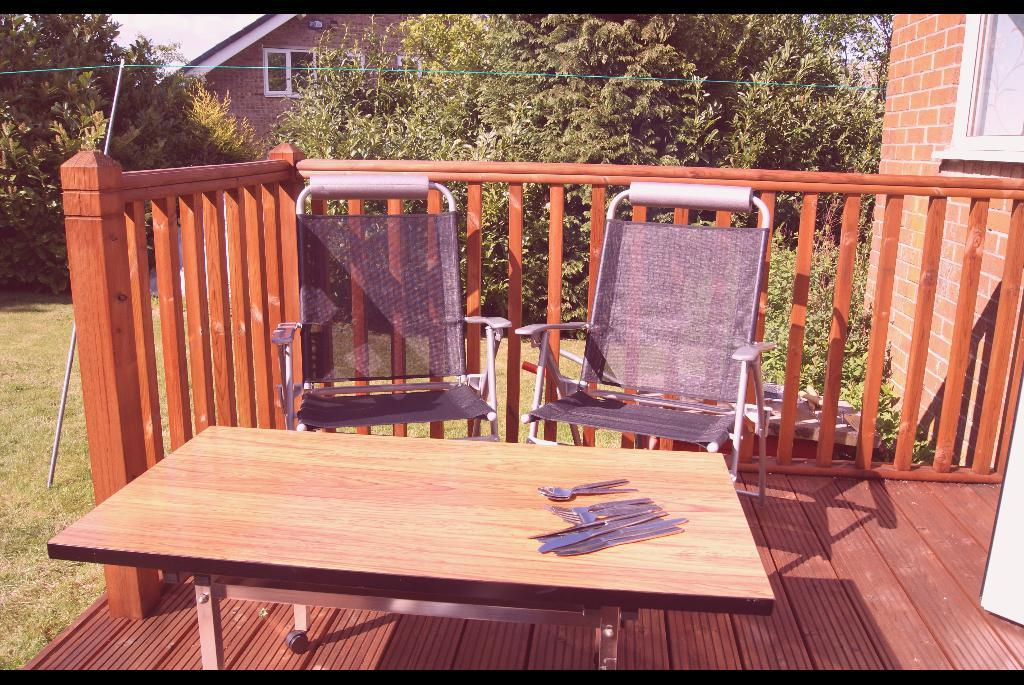What type of wall is visible in the image? There is a brick wall in the image. What can be seen through the windows in the image? The presence of windows suggests that there may be a view or another room visible through them, but the specifics are not mentioned in the facts. What material is used for the railing in the image? There is a wooden railing in the image. What piece of furniture is present in the image? There is a table in the image. What utensils can be seen in the image? There are forks and knives in the image. What type of surface is present in the image? There is a wooden surface in the image. What type of seating is visible in the image? There are chairs in the image. What type of natural environment is visible in the image? There is grass in the image, which suggests a natural setting. What additional object can be seen in the image? There is a rod in the image. What type of structure is visible in the image? There is a house in the image. What type of vegetation is visible in the image? There are plants and trees in the image. Can you tell me how many spoons are visible in the image? There is no mention of spoons in the provided facts, so it cannot be determined from the image. What type of swing is present in the image? There is no swing present in the image. 